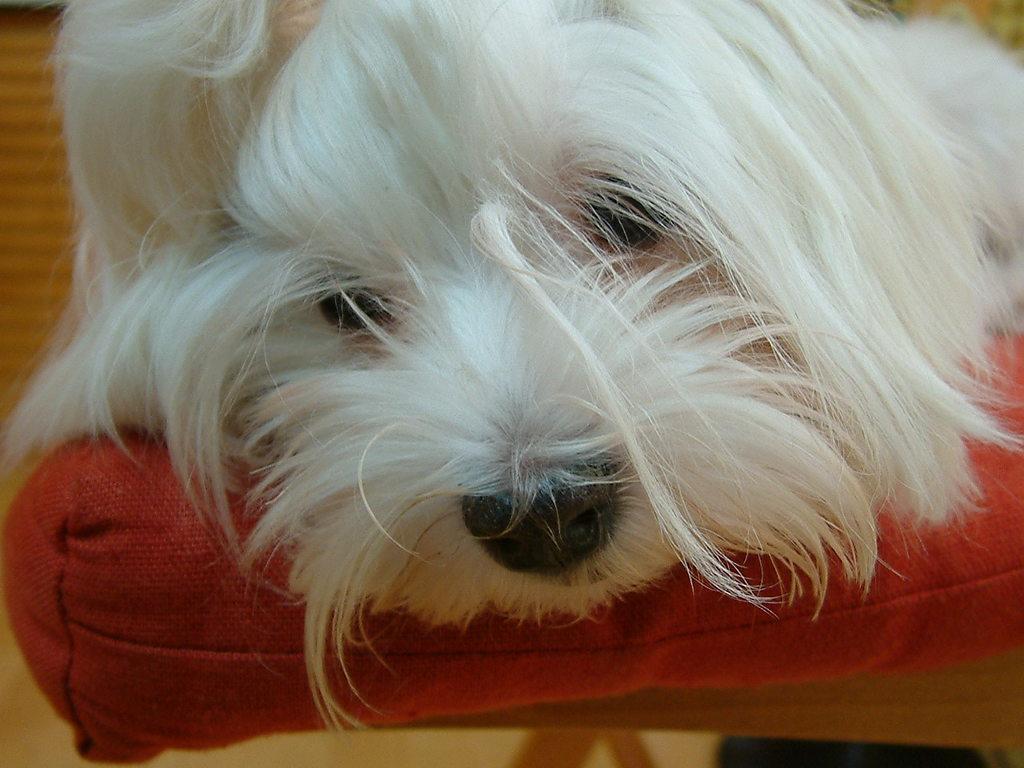Please provide a concise description of this image. In this picture we can observe a white color dog on the red color seat. We can observe fur on the face of this dog. 